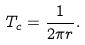Convert formula to latex. <formula><loc_0><loc_0><loc_500><loc_500>T _ { c } = \frac { 1 } { 2 \pi r } .</formula> 